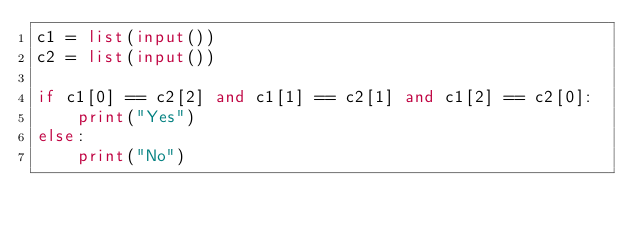Convert code to text. <code><loc_0><loc_0><loc_500><loc_500><_Python_>c1 = list(input())
c2 = list(input())

if c1[0] == c2[2] and c1[1] == c2[1] and c1[2] == c2[0]:
    print("Yes")
else:
    print("No")
    

</code> 